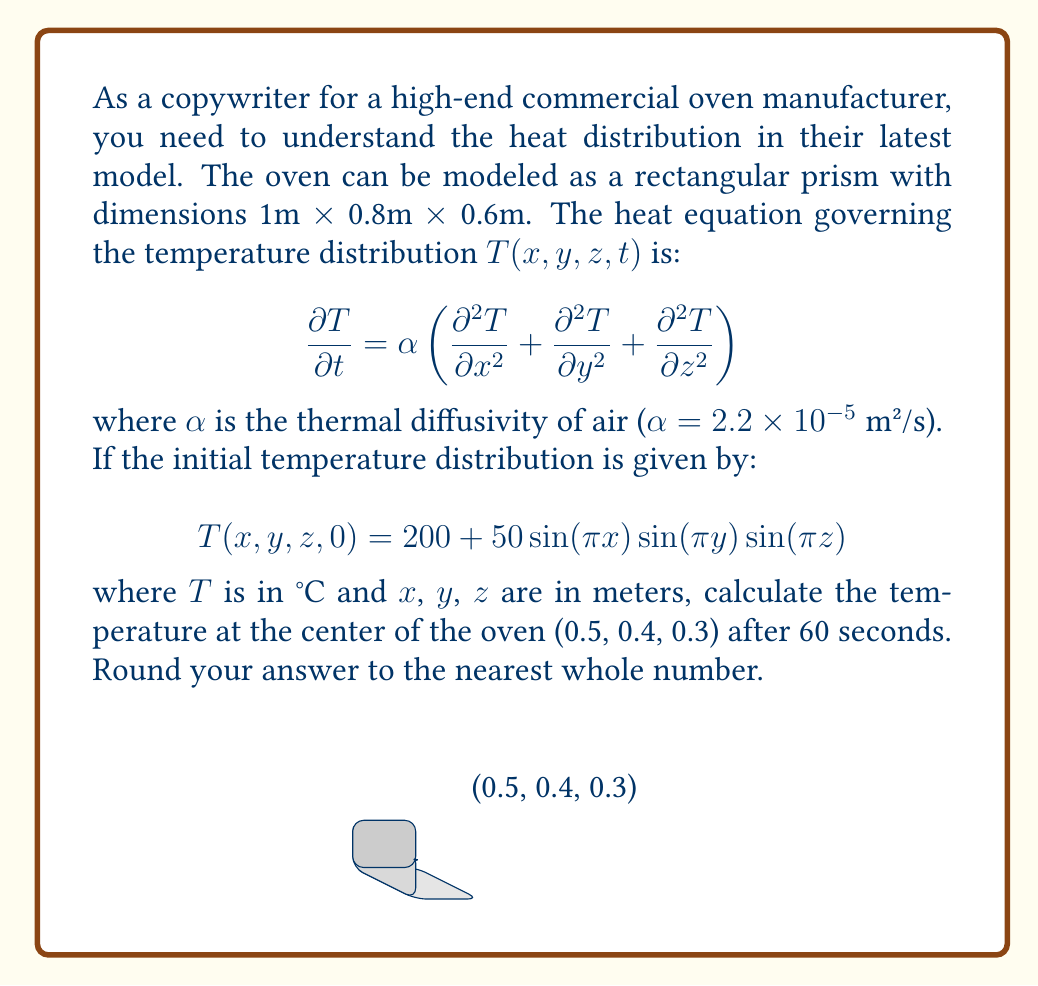Can you solve this math problem? To solve this problem, we'll use the separation of variables method for the heat equation in 3D. The solution will have the form:

$$T(x,y,z,t) = (200 + 50\sin(\pi x)\sin(\pi y)\sin(\pi z))e^{-\alpha\pi^2(1^2+1^2+1^2)t}$$

Let's break down the solution step-by-step:

1) First, we need to calculate the exponent:
   $$-\alpha\pi^2(1^2+1^2+1^2) = -(2.2 \times 10^{-5})\pi^2(3) = -6.5973 \times 10^{-4}$$

2) Now, we can calculate the exponential term for t = 60s:
   $$e^{-6.5973 \times 10^{-4} \times 60} = 0.9613$$

3) Next, we evaluate the sine terms at the center point (0.5, 0.4, 0.3):
   $$\sin(\pi \times 0.5) \times \sin(\pi \times 0.4) \times \sin(\pi \times 0.3)$$
   $$= 1 \times 0.9511 \times 0.8090 = 0.7693$$

4) Now we can put it all together:
   $$T(0.5,0.4,0.3,60) = (200 + 50 \times 0.7693 \times 0.9613)$$
   $$= 200 + 36.98 = 236.98°C$$

5) Rounding to the nearest whole number:
   $$236.98°C \approx 237°C$$
Answer: 237°C 